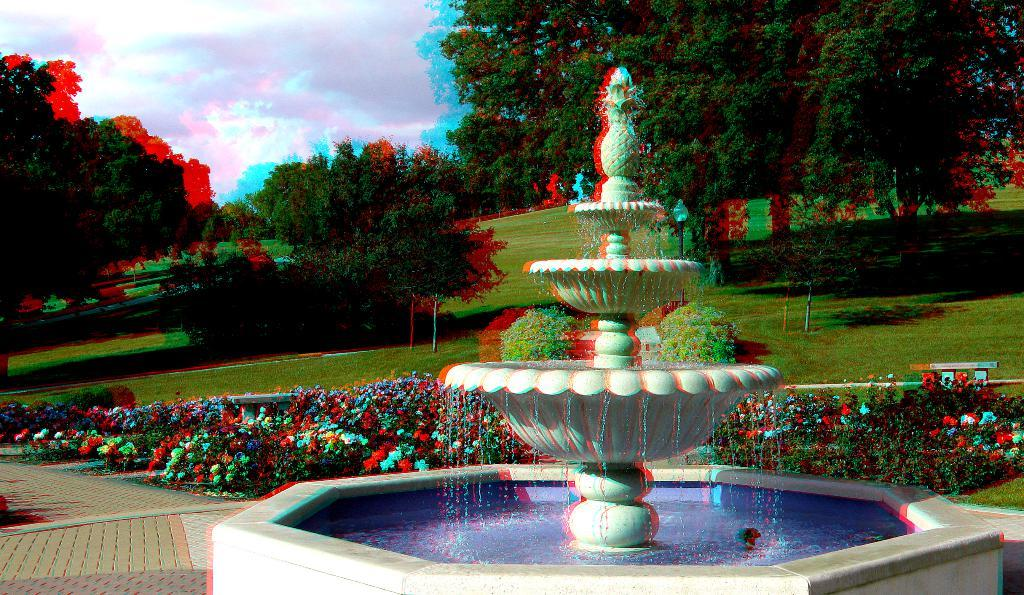What is the main feature in the image? There is a fountain with water in the image. What can be seen near the fountain? There is a path in the image. What type of vegetation is present in the image? Flowers, plants, and trees are visible in the image. What is the ground made of? Grass is present in the image. Are there any objects in the image? Yes, there are objects in the image. What is visible in the background of the image? The sky is visible in the background of the image. What can be seen in the sky? Clouds are present in the sky. How many dogs are walking on the line in the image? There are no dogs or lines present in the image. What type of magic is being performed by the fountain in the image? There is no magic present in the image. 